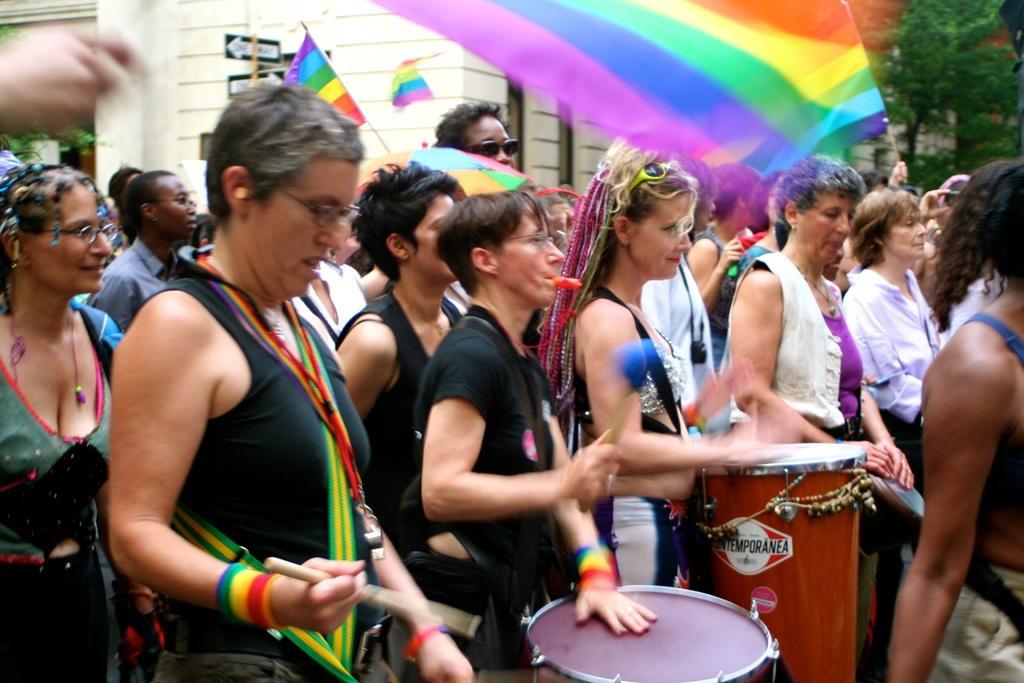Could you give a brief overview of what you see in this image? In this image I a see group of people among them few are playing drums and few are holding flags in their hand. 